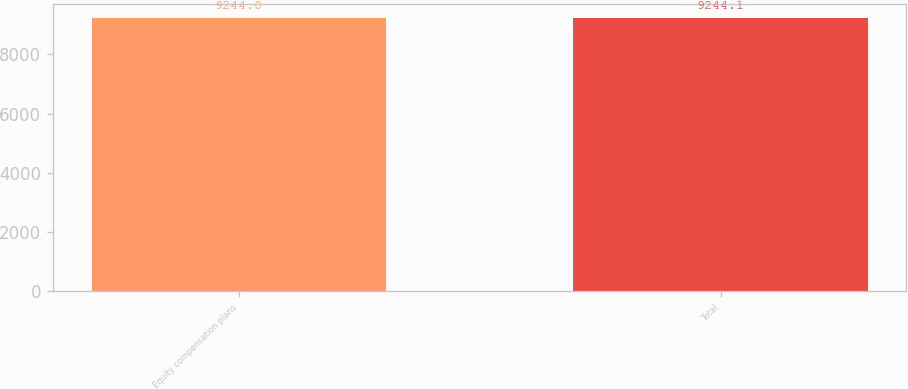Convert chart. <chart><loc_0><loc_0><loc_500><loc_500><bar_chart><fcel>Equity compensation plans<fcel>Total<nl><fcel>9244<fcel>9244.1<nl></chart> 